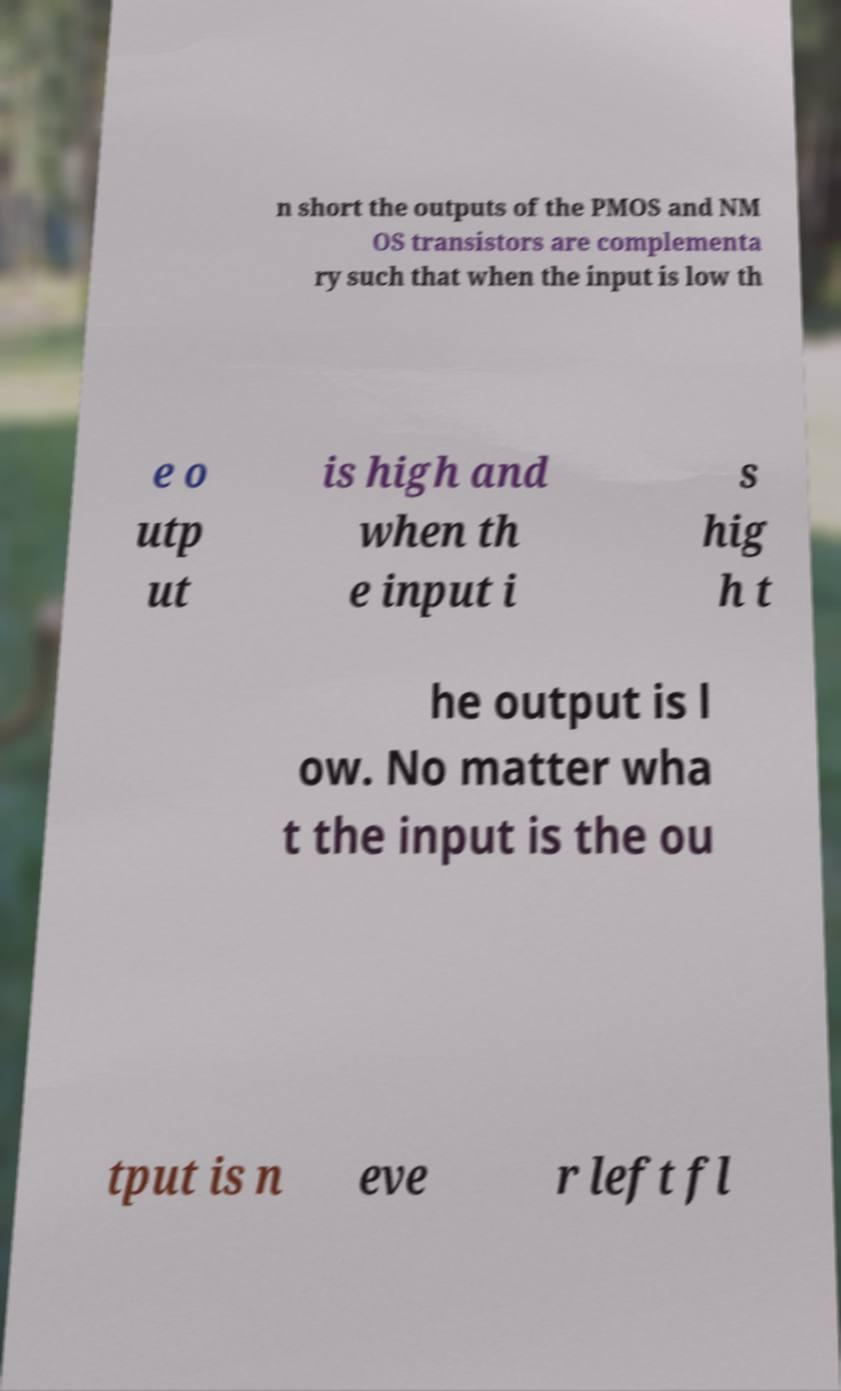What messages or text are displayed in this image? I need them in a readable, typed format. n short the outputs of the PMOS and NM OS transistors are complementa ry such that when the input is low th e o utp ut is high and when th e input i s hig h t he output is l ow. No matter wha t the input is the ou tput is n eve r left fl 